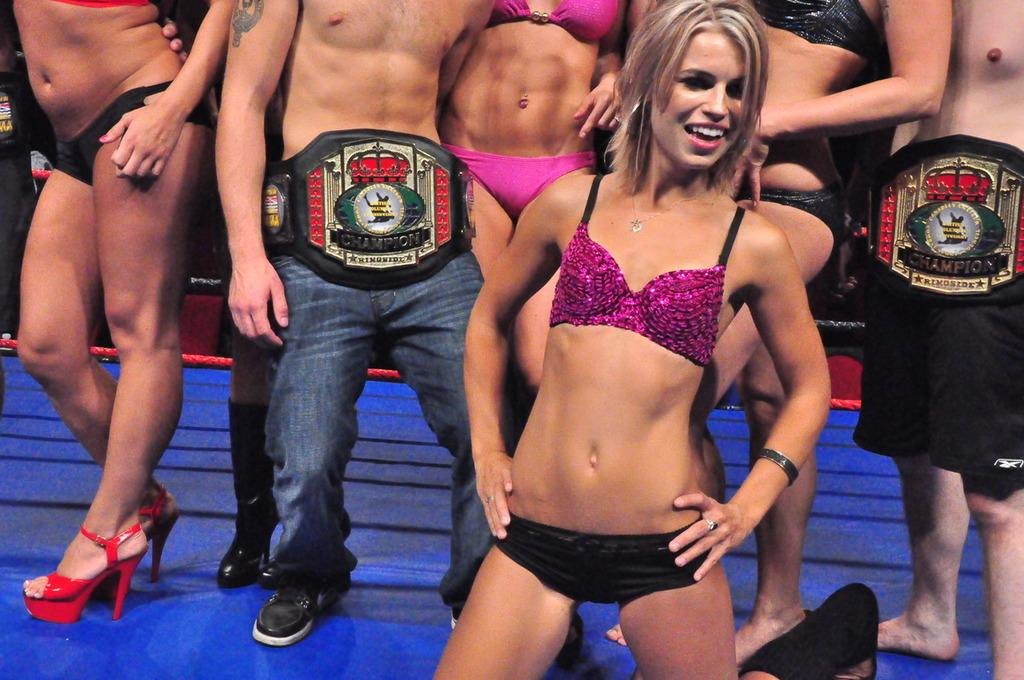What types of people are present in the image? There are men and women in the image. What are the men and women doing in the image? The men and women are standing on the floor. What type of bucket is being used for arithmetic calculations in the image? There is no bucket or arithmetic calculations present in the image. What is the son of the man doing in the image? There is no son present in the image. 